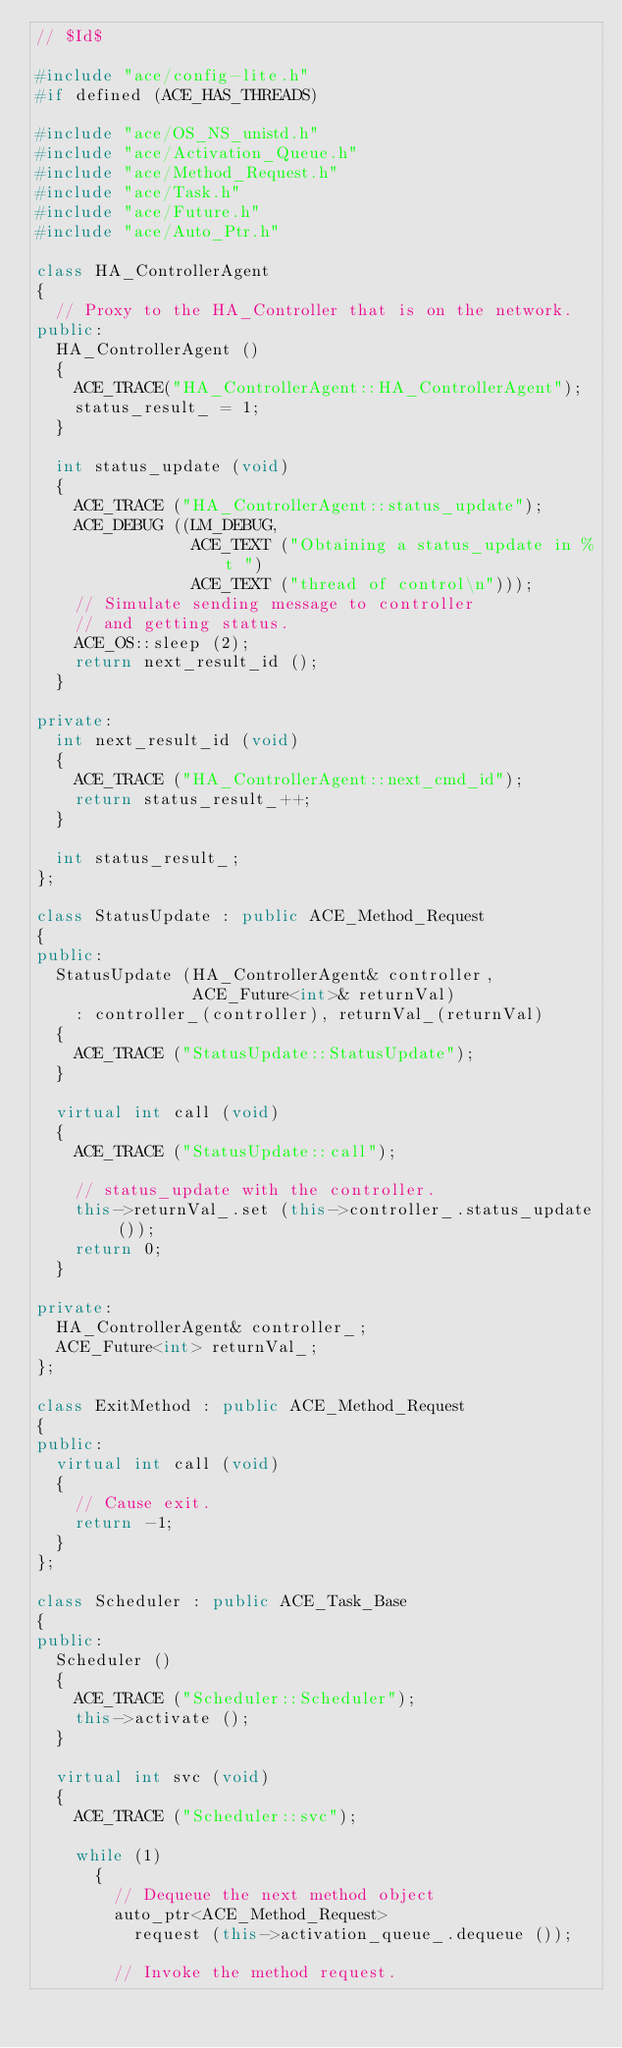<code> <loc_0><loc_0><loc_500><loc_500><_C++_>// $Id$

#include "ace/config-lite.h"
#if defined (ACE_HAS_THREADS)

#include "ace/OS_NS_unistd.h"
#include "ace/Activation_Queue.h"
#include "ace/Method_Request.h"
#include "ace/Task.h"
#include "ace/Future.h"
#include "ace/Auto_Ptr.h"

class HA_ControllerAgent
{
  // Proxy to the HA_Controller that is on the network.
public:
  HA_ControllerAgent ()
  {
    ACE_TRACE("HA_ControllerAgent::HA_ControllerAgent");
    status_result_ = 1;
  }

  int status_update (void)
  {
    ACE_TRACE ("HA_ControllerAgent::status_update");
    ACE_DEBUG ((LM_DEBUG,
                ACE_TEXT ("Obtaining a status_update in %t ")
                ACE_TEXT ("thread of control\n")));
    // Simulate sending message to controller
    // and getting status.
    ACE_OS::sleep (2);
    return next_result_id ();
  }

private:
  int next_result_id (void)
  {
    ACE_TRACE ("HA_ControllerAgent::next_cmd_id");
    return status_result_++;
  }

  int status_result_;
};

class StatusUpdate : public ACE_Method_Request
{
public:
  StatusUpdate (HA_ControllerAgent& controller,
                ACE_Future<int>& returnVal)
    : controller_(controller), returnVal_(returnVal)
  {
    ACE_TRACE ("StatusUpdate::StatusUpdate");
  }

  virtual int call (void)
  {
    ACE_TRACE ("StatusUpdate::call");

    // status_update with the controller.
    this->returnVal_.set (this->controller_.status_update ());
    return 0;
  }

private:
  HA_ControllerAgent& controller_;
  ACE_Future<int> returnVal_;
};

class ExitMethod : public ACE_Method_Request
{
public:
  virtual int call (void)
  {
    // Cause exit.
    return -1;
  }
};

class Scheduler : public ACE_Task_Base
{
public:
  Scheduler ()
  {
    ACE_TRACE ("Scheduler::Scheduler");
    this->activate ();
  }

  virtual int svc (void)
  {
    ACE_TRACE ("Scheduler::svc");

    while (1)
      {
        // Dequeue the next method object
        auto_ptr<ACE_Method_Request>
          request (this->activation_queue_.dequeue ());

        // Invoke the method request.</code> 